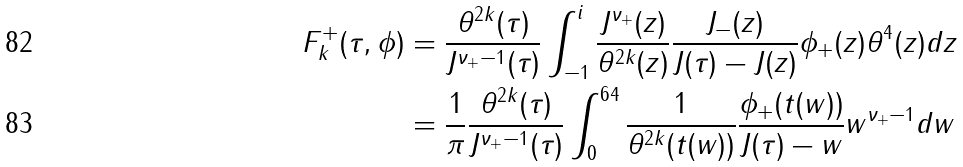<formula> <loc_0><loc_0><loc_500><loc_500>F _ { k } ^ { + } ( \tau , \phi ) & = \frac { \theta ^ { 2 k } ( \tau ) } { J ^ { \nu _ { + } - 1 } ( \tau ) } \int _ { - 1 } ^ { i } \frac { J ^ { \nu _ { + } } ( z ) } { \theta ^ { 2 k } ( z ) } \frac { J _ { - } ( z ) } { J ( \tau ) - J ( z ) } \phi _ { + } ( z ) \theta ^ { 4 } ( z ) d z \\ & = \frac { 1 } { \pi } \frac { \theta ^ { 2 k } ( \tau ) } { J ^ { \nu _ { + } - 1 } ( \tau ) } \int _ { 0 } ^ { 6 4 } \frac { 1 } { \theta ^ { 2 k } ( t ( w ) ) } \frac { \phi _ { + } ( t ( w ) ) } { J ( \tau ) - w } w ^ { \nu _ { + } - 1 } d w</formula> 